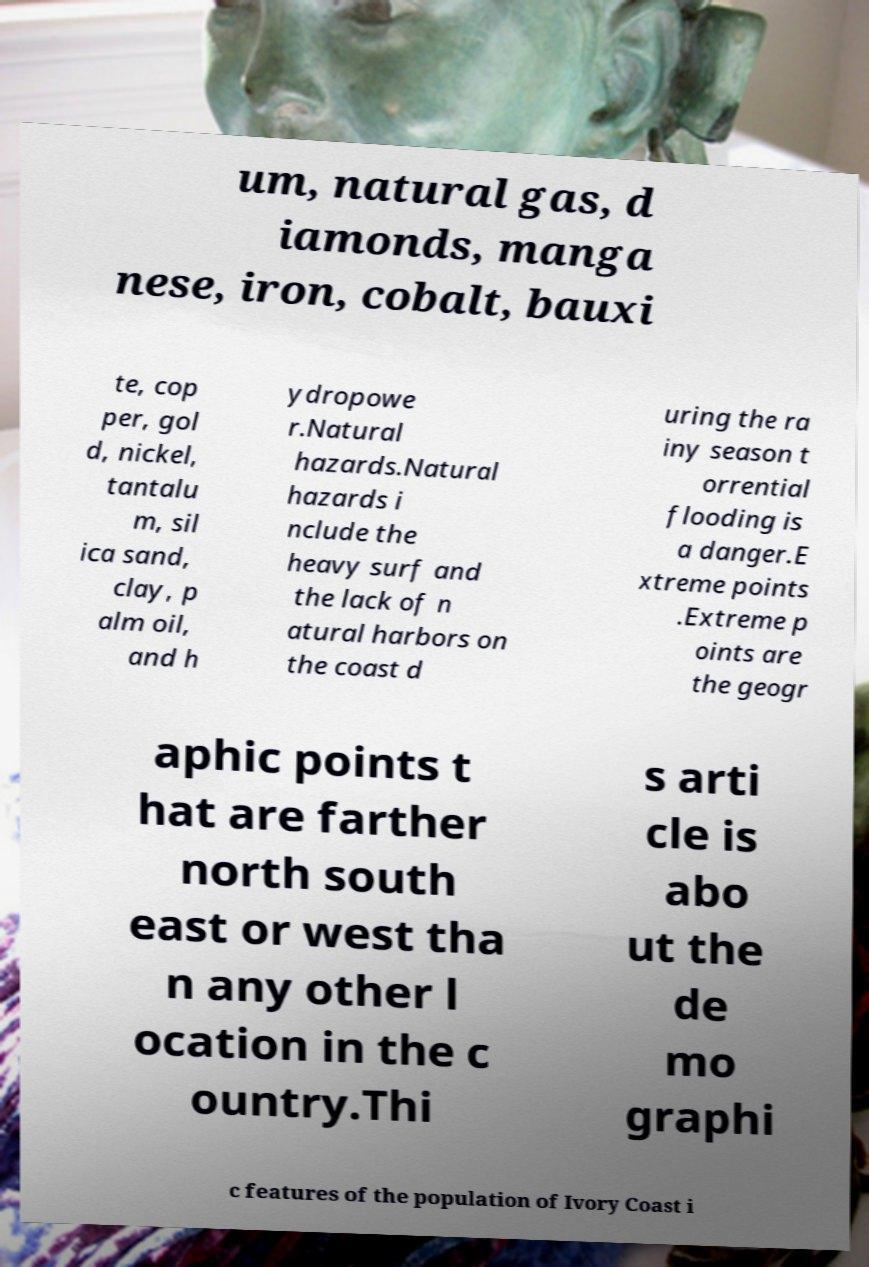Can you accurately transcribe the text from the provided image for me? um, natural gas, d iamonds, manga nese, iron, cobalt, bauxi te, cop per, gol d, nickel, tantalu m, sil ica sand, clay, p alm oil, and h ydropowe r.Natural hazards.Natural hazards i nclude the heavy surf and the lack of n atural harbors on the coast d uring the ra iny season t orrential flooding is a danger.E xtreme points .Extreme p oints are the geogr aphic points t hat are farther north south east or west tha n any other l ocation in the c ountry.Thi s arti cle is abo ut the de mo graphi c features of the population of Ivory Coast i 